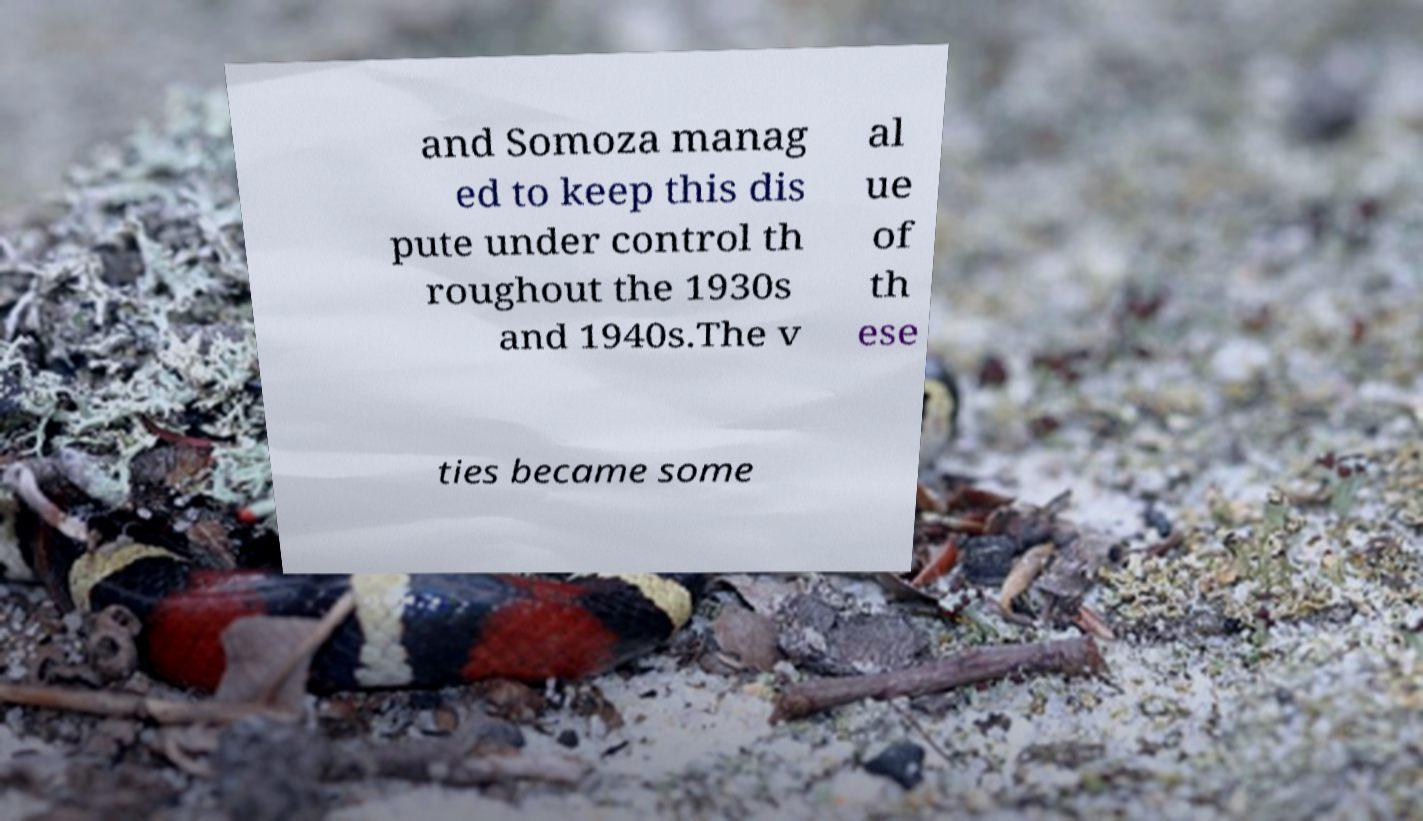There's text embedded in this image that I need extracted. Can you transcribe it verbatim? and Somoza manag ed to keep this dis pute under control th roughout the 1930s and 1940s.The v al ue of th ese ties became some 